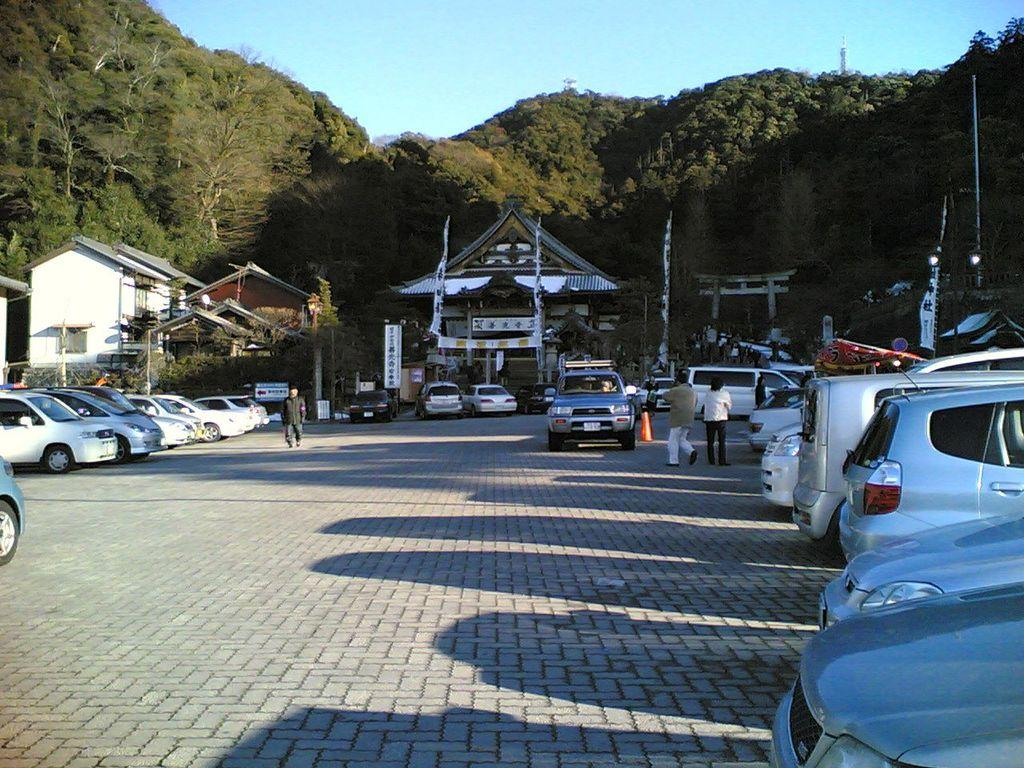What type of vehicles can be seen in the image? There are cars in the image. What are the people in the image doing? There are persons standing and walking in the image. What can be seen in the background of the image? There are buildings, trees, and flags in the background of the image. What type of baseball game is being played in the image? There is no baseball game present in the image. What is the purpose of the flags in the image? The purpose of the flags cannot be determined from the image alone, as there is no context provided. 